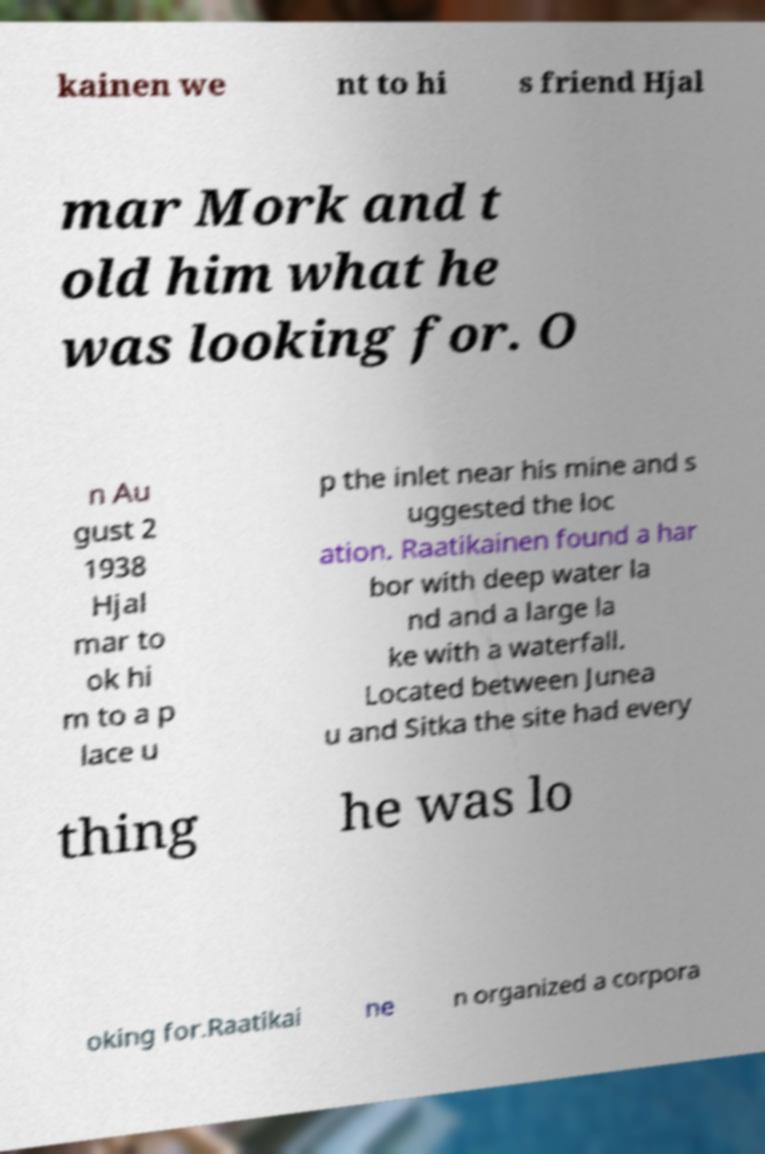I need the written content from this picture converted into text. Can you do that? kainen we nt to hi s friend Hjal mar Mork and t old him what he was looking for. O n Au gust 2 1938 Hjal mar to ok hi m to a p lace u p the inlet near his mine and s uggested the loc ation. Raatikainen found a har bor with deep water la nd and a large la ke with a waterfall. Located between Junea u and Sitka the site had every thing he was lo oking for.Raatikai ne n organized a corpora 